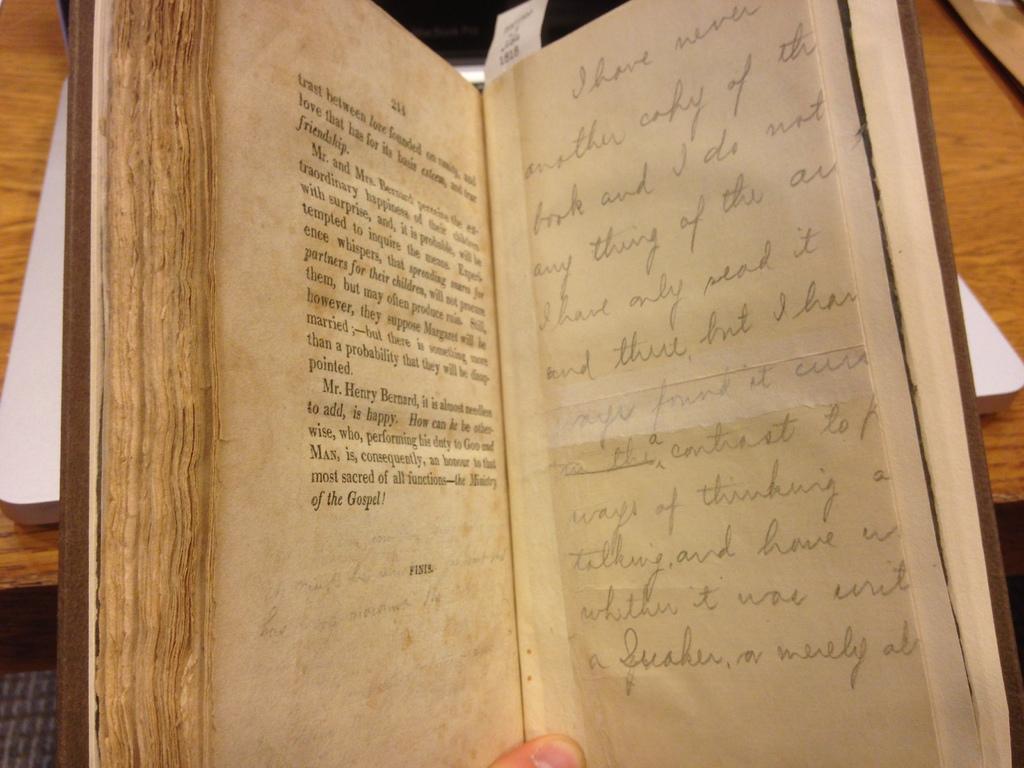Which page is the book on?
Offer a very short reply. 214. 